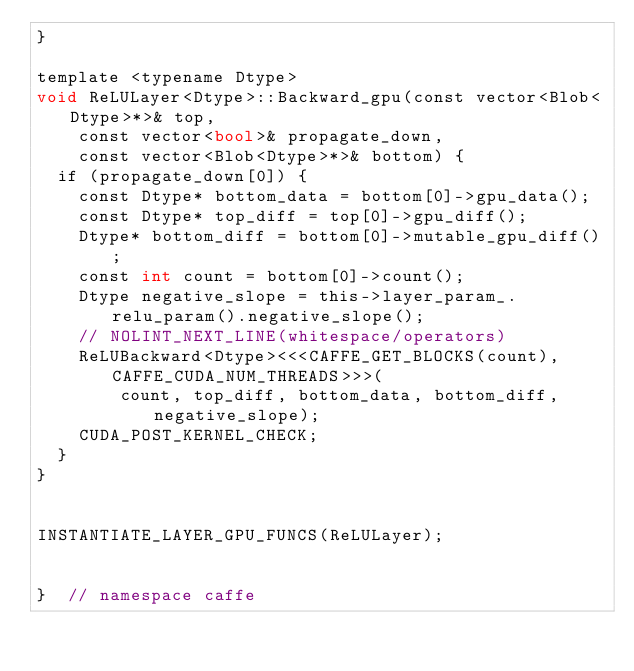<code> <loc_0><loc_0><loc_500><loc_500><_Cuda_>}

template <typename Dtype>
void ReLULayer<Dtype>::Backward_gpu(const vector<Blob<Dtype>*>& top,
    const vector<bool>& propagate_down,
    const vector<Blob<Dtype>*>& bottom) {
  if (propagate_down[0]) {
    const Dtype* bottom_data = bottom[0]->gpu_data();
    const Dtype* top_diff = top[0]->gpu_diff();
    Dtype* bottom_diff = bottom[0]->mutable_gpu_diff();
    const int count = bottom[0]->count();
    Dtype negative_slope = this->layer_param_.relu_param().negative_slope();
    // NOLINT_NEXT_LINE(whitespace/operators)
    ReLUBackward<Dtype><<<CAFFE_GET_BLOCKS(count), CAFFE_CUDA_NUM_THREADS>>>(
        count, top_diff, bottom_data, bottom_diff, negative_slope);
    CUDA_POST_KERNEL_CHECK;
  }
}


INSTANTIATE_LAYER_GPU_FUNCS(ReLULayer);


}  // namespace caffe
</code> 